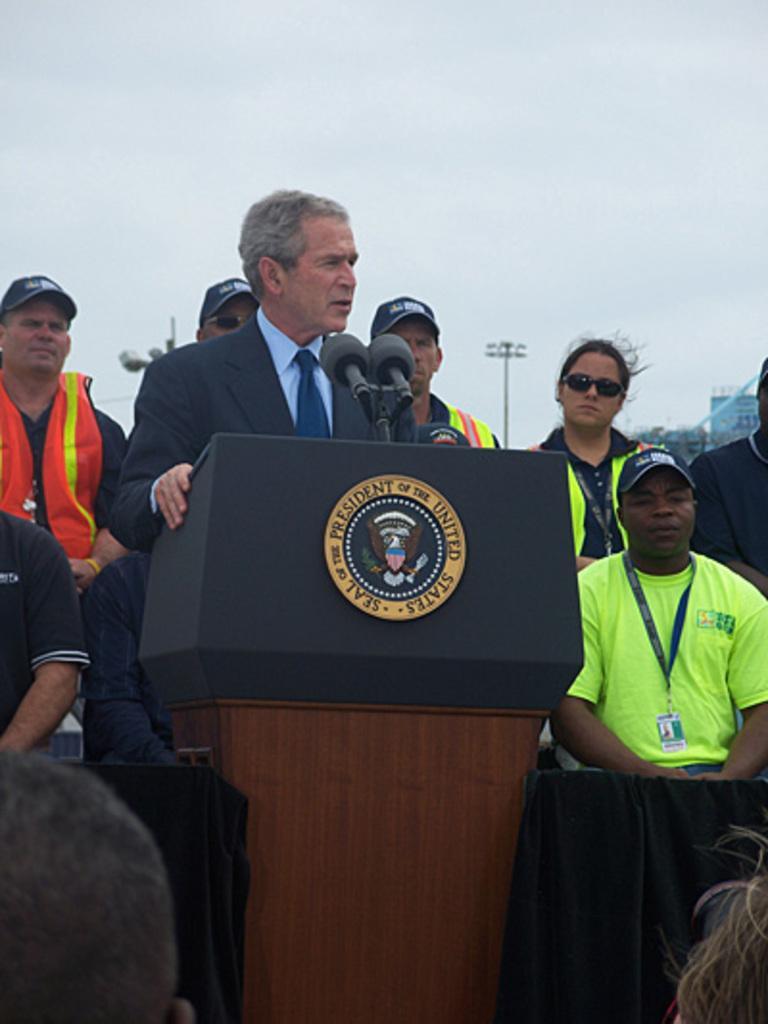How would you summarize this image in a sentence or two? In the image I can see a person who is wearing the suit and standing in front of the desk on which there is a mic and also I can see some other people and a pole. 